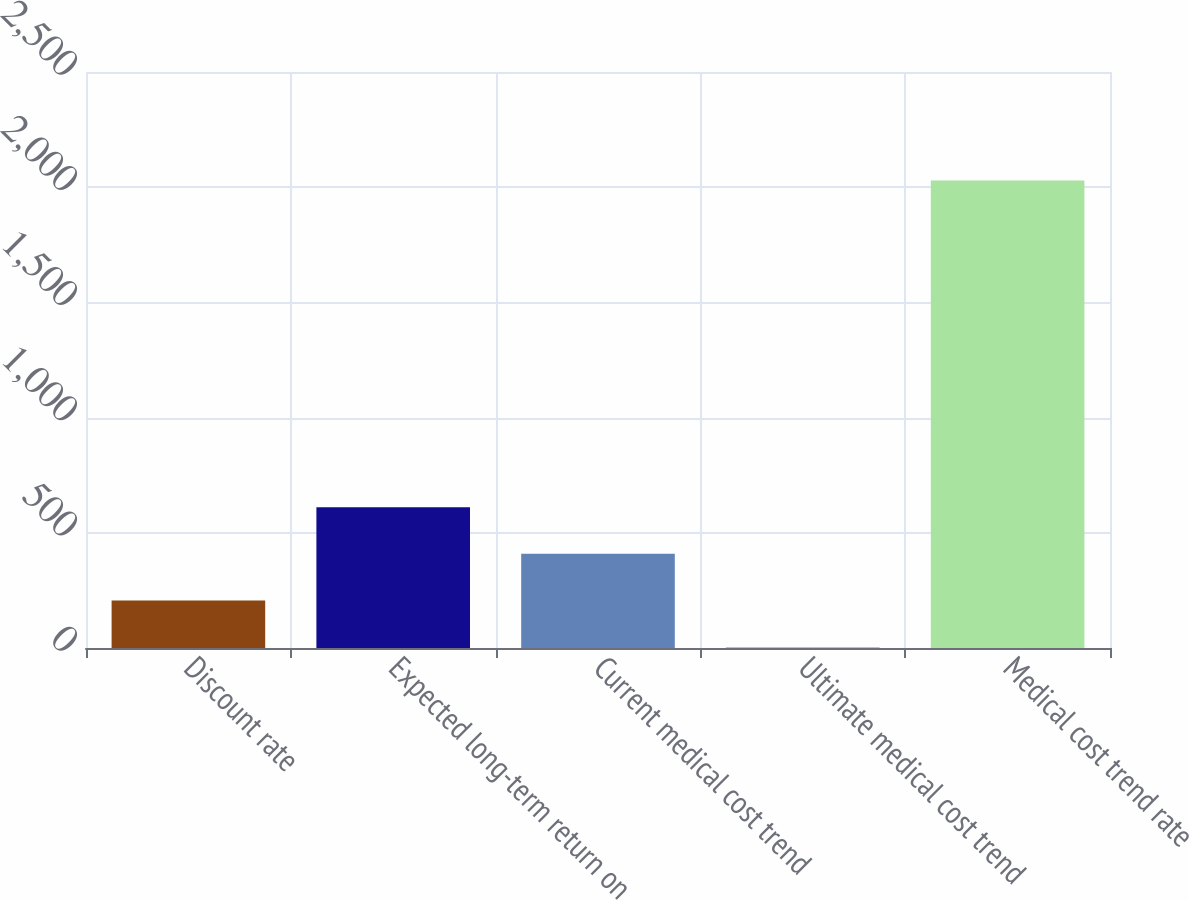Convert chart to OTSL. <chart><loc_0><loc_0><loc_500><loc_500><bar_chart><fcel>Discount rate<fcel>Expected long-term return on<fcel>Current medical cost trend<fcel>Ultimate medical cost trend<fcel>Medical cost trend rate<nl><fcel>206.05<fcel>611.15<fcel>408.6<fcel>3.5<fcel>2029<nl></chart> 